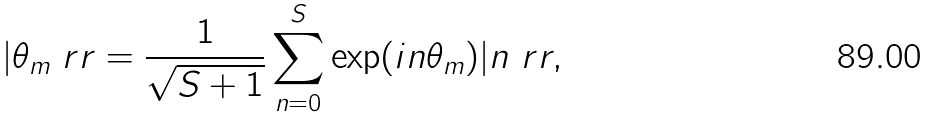<formula> <loc_0><loc_0><loc_500><loc_500>| \theta _ { m } \ r r = \frac { 1 } { \sqrt { S + 1 } } \sum _ { n = 0 } ^ { S } \exp ( i n \theta _ { m } ) | n \ r r ,</formula> 